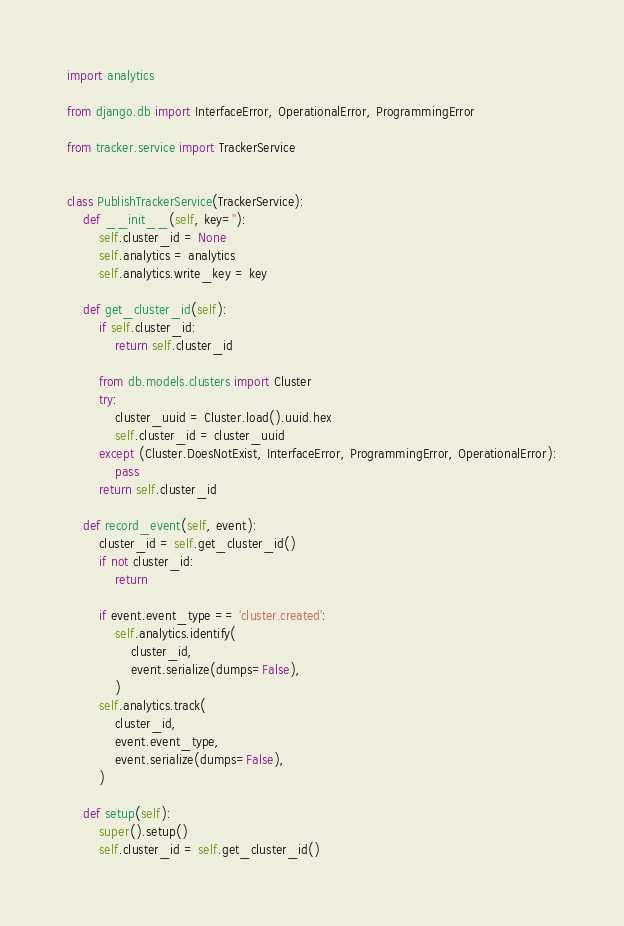<code> <loc_0><loc_0><loc_500><loc_500><_Python_>import analytics

from django.db import InterfaceError, OperationalError, ProgrammingError

from tracker.service import TrackerService


class PublishTrackerService(TrackerService):
    def __init__(self, key=''):
        self.cluster_id = None
        self.analytics = analytics
        self.analytics.write_key = key

    def get_cluster_id(self):
        if self.cluster_id:
            return self.cluster_id

        from db.models.clusters import Cluster
        try:
            cluster_uuid = Cluster.load().uuid.hex
            self.cluster_id = cluster_uuid
        except (Cluster.DoesNotExist, InterfaceError, ProgrammingError, OperationalError):
            pass
        return self.cluster_id

    def record_event(self, event):
        cluster_id = self.get_cluster_id()
        if not cluster_id:
            return

        if event.event_type == 'cluster.created':
            self.analytics.identify(
                cluster_id,
                event.serialize(dumps=False),
            )
        self.analytics.track(
            cluster_id,
            event.event_type,
            event.serialize(dumps=False),
        )

    def setup(self):
        super().setup()
        self.cluster_id = self.get_cluster_id()
</code> 